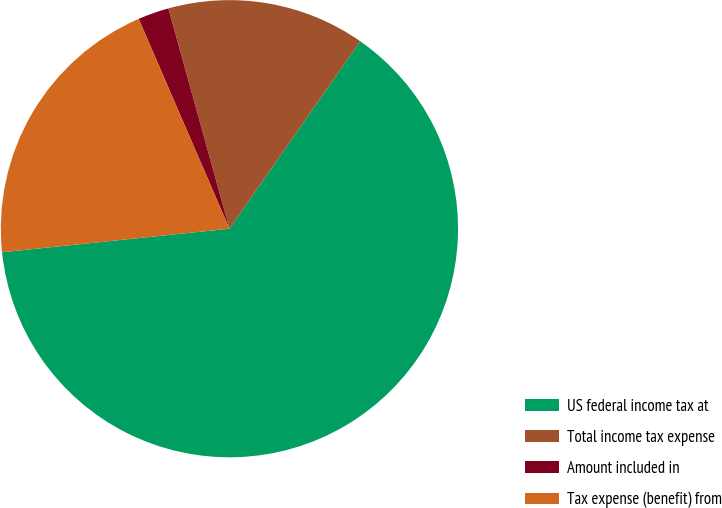Convert chart to OTSL. <chart><loc_0><loc_0><loc_500><loc_500><pie_chart><fcel>US federal income tax at<fcel>Total income tax expense<fcel>Amount included in<fcel>Tax expense (benefit) from<nl><fcel>63.66%<fcel>14.0%<fcel>2.19%<fcel>20.15%<nl></chart> 